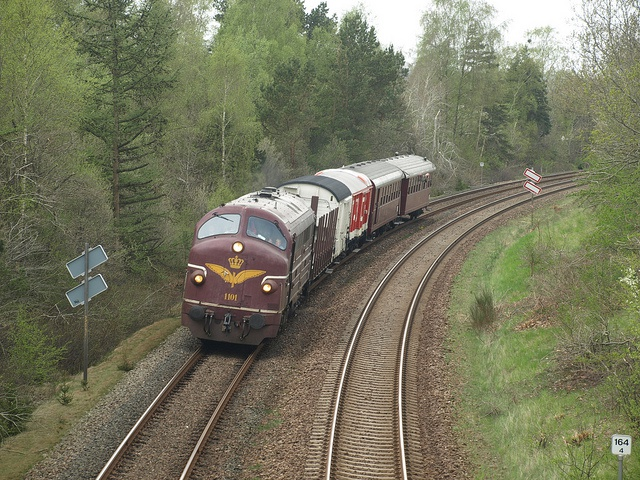Describe the objects in this image and their specific colors. I can see a train in olive, gray, black, lightgray, and darkgray tones in this image. 